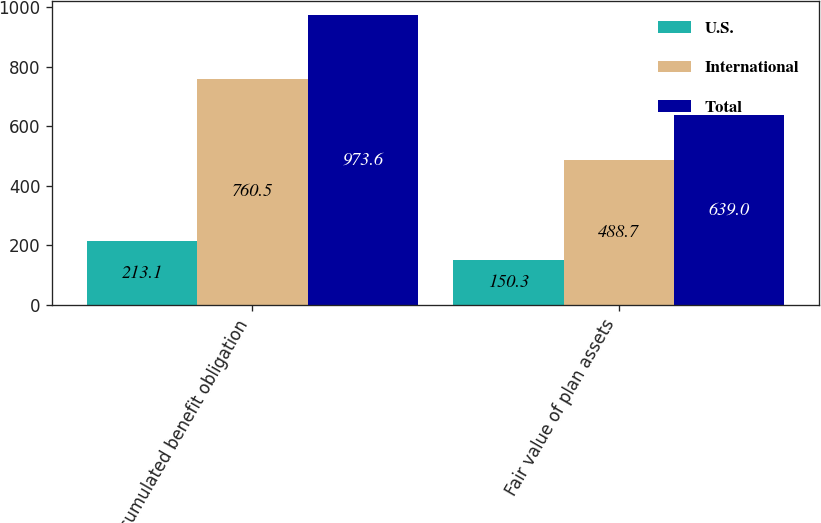Convert chart to OTSL. <chart><loc_0><loc_0><loc_500><loc_500><stacked_bar_chart><ecel><fcel>Accumulated benefit obligation<fcel>Fair value of plan assets<nl><fcel>U.S.<fcel>213.1<fcel>150.3<nl><fcel>International<fcel>760.5<fcel>488.7<nl><fcel>Total<fcel>973.6<fcel>639<nl></chart> 